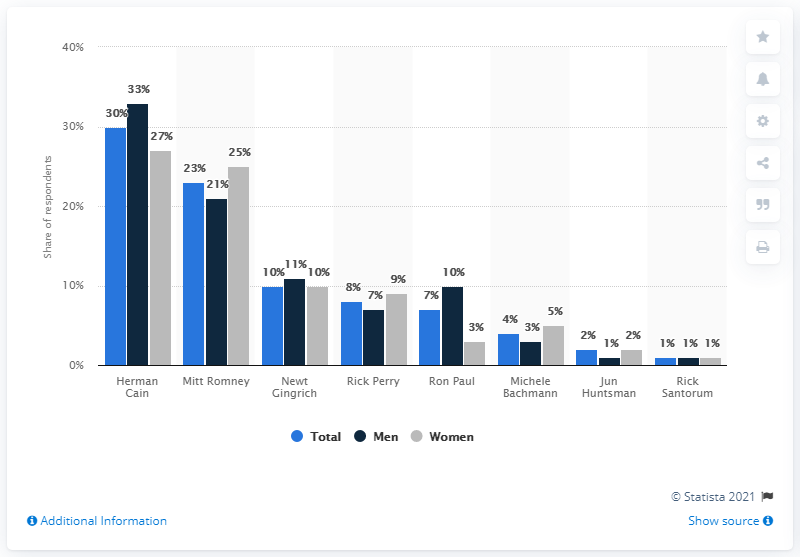Outline some significant characteristics in this image. Mitt Romney would lose to Herman Cain if he were elected president. 